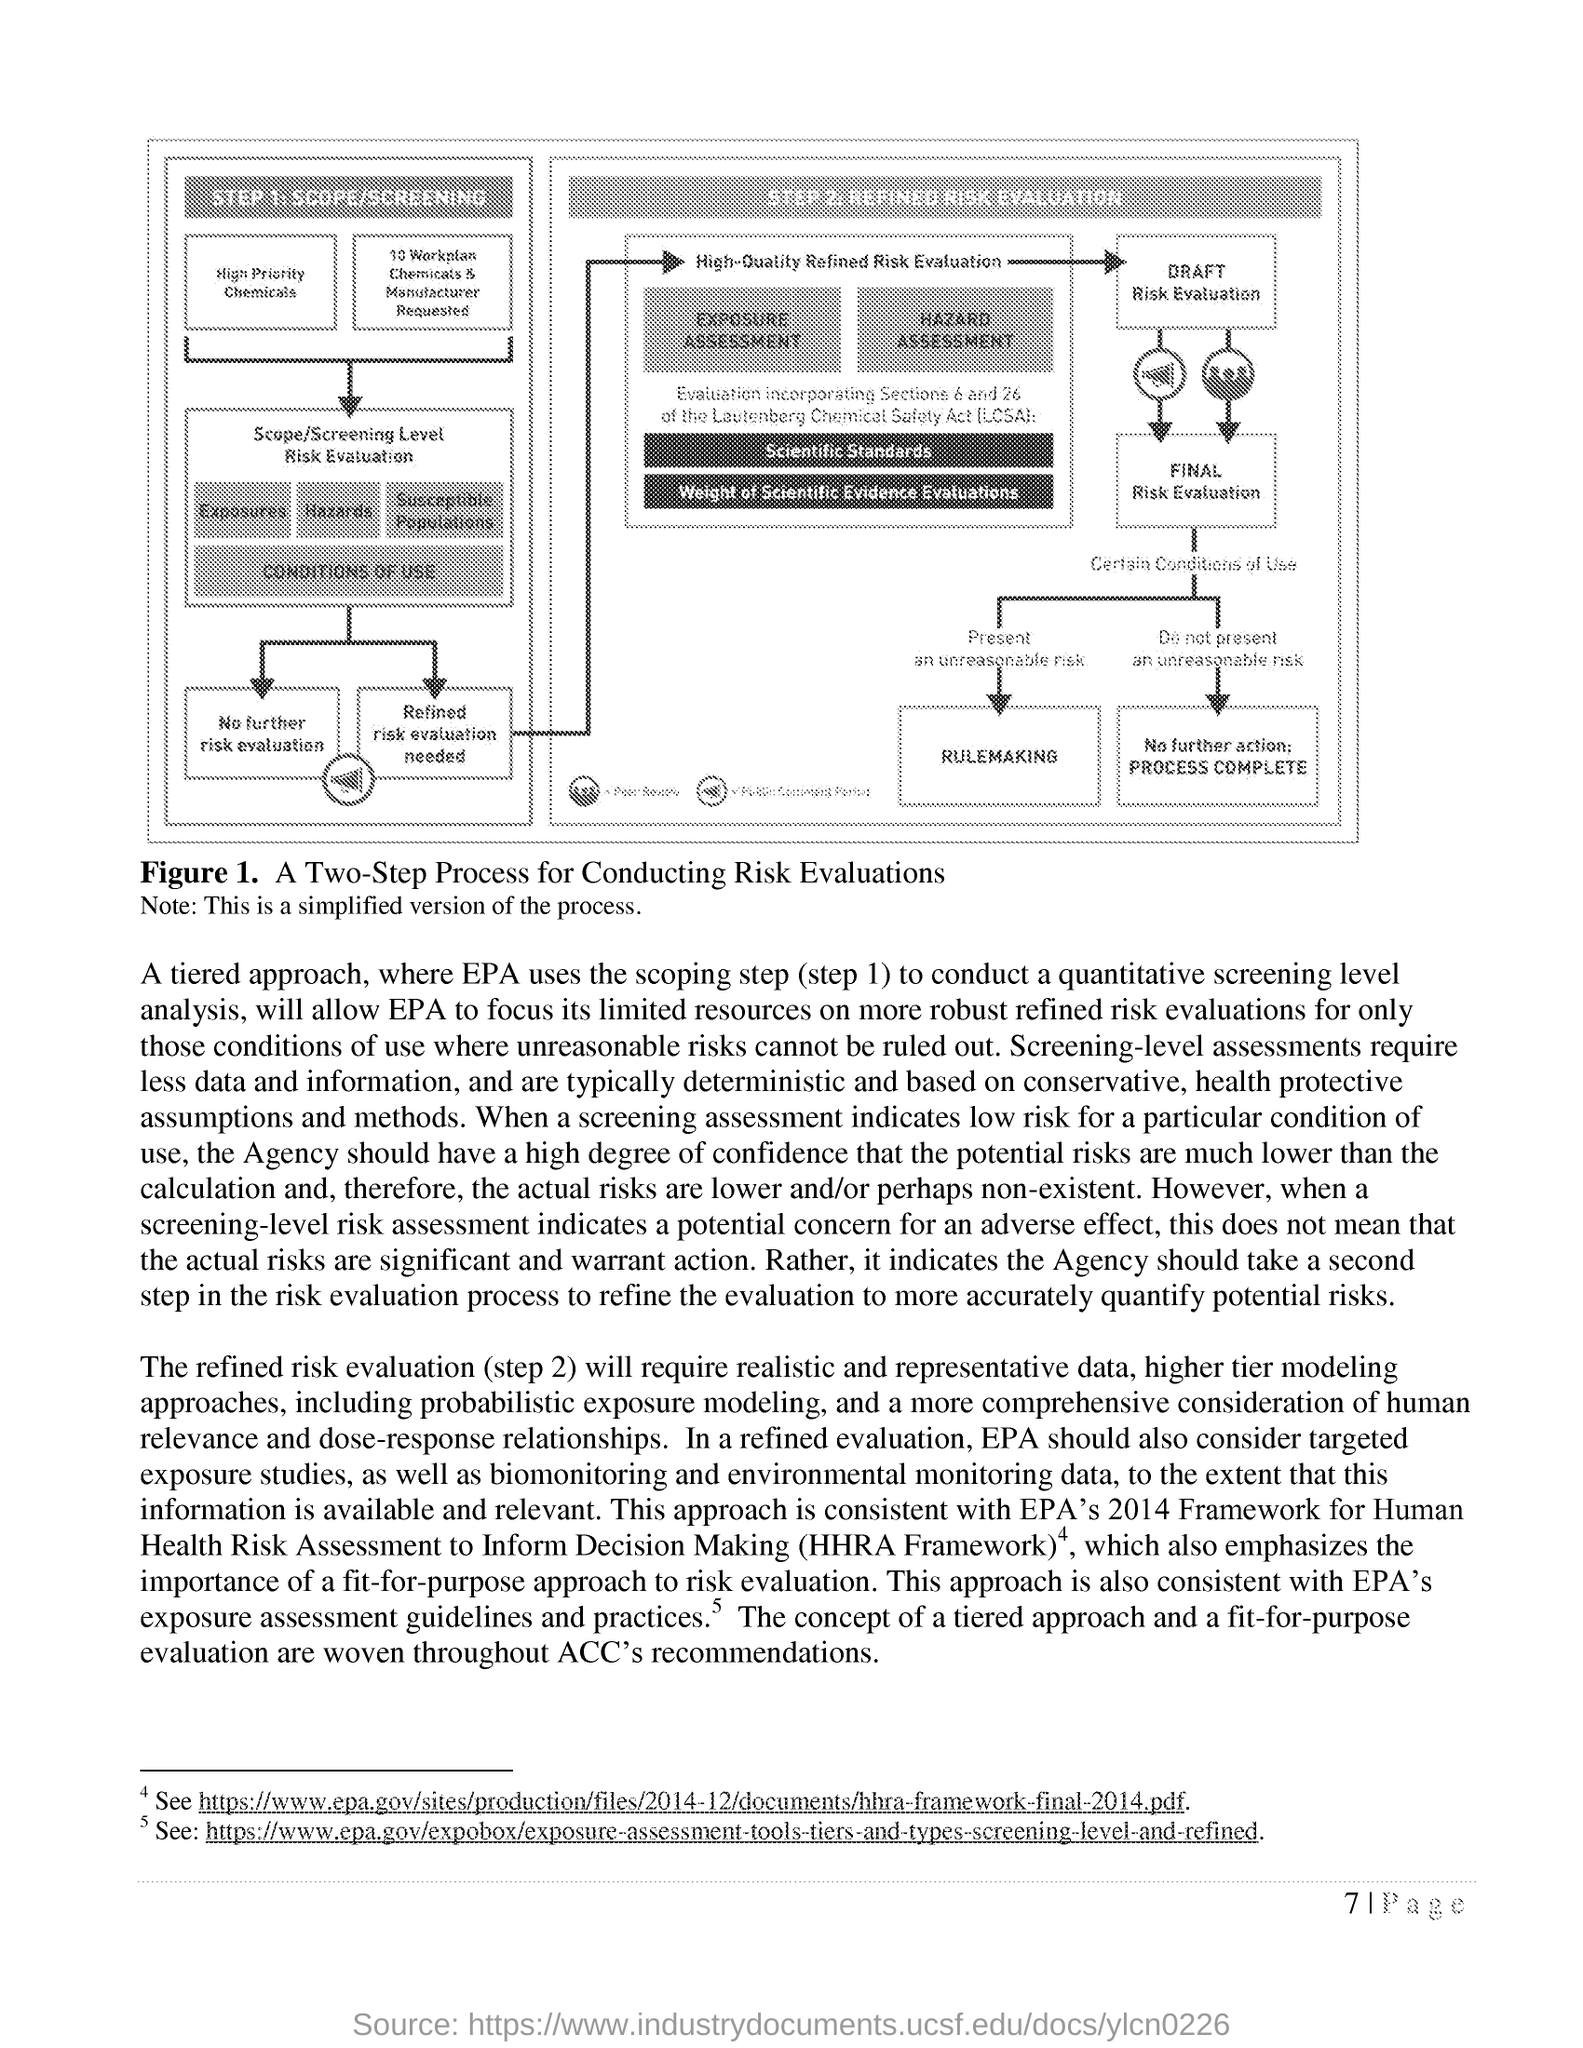What does the Figure 1 show?
Your answer should be very brief. A Two-step Process for Conducting Risk Evaluations. What is the next step in the diagram after Present an unreasonable risk?
Your answer should be very brief. Rulemaking. What is the name of STEP 2?
Provide a succinct answer. REFINED RISK EVALUATION. What is the page number of this document?
Your response must be concise. 7. 